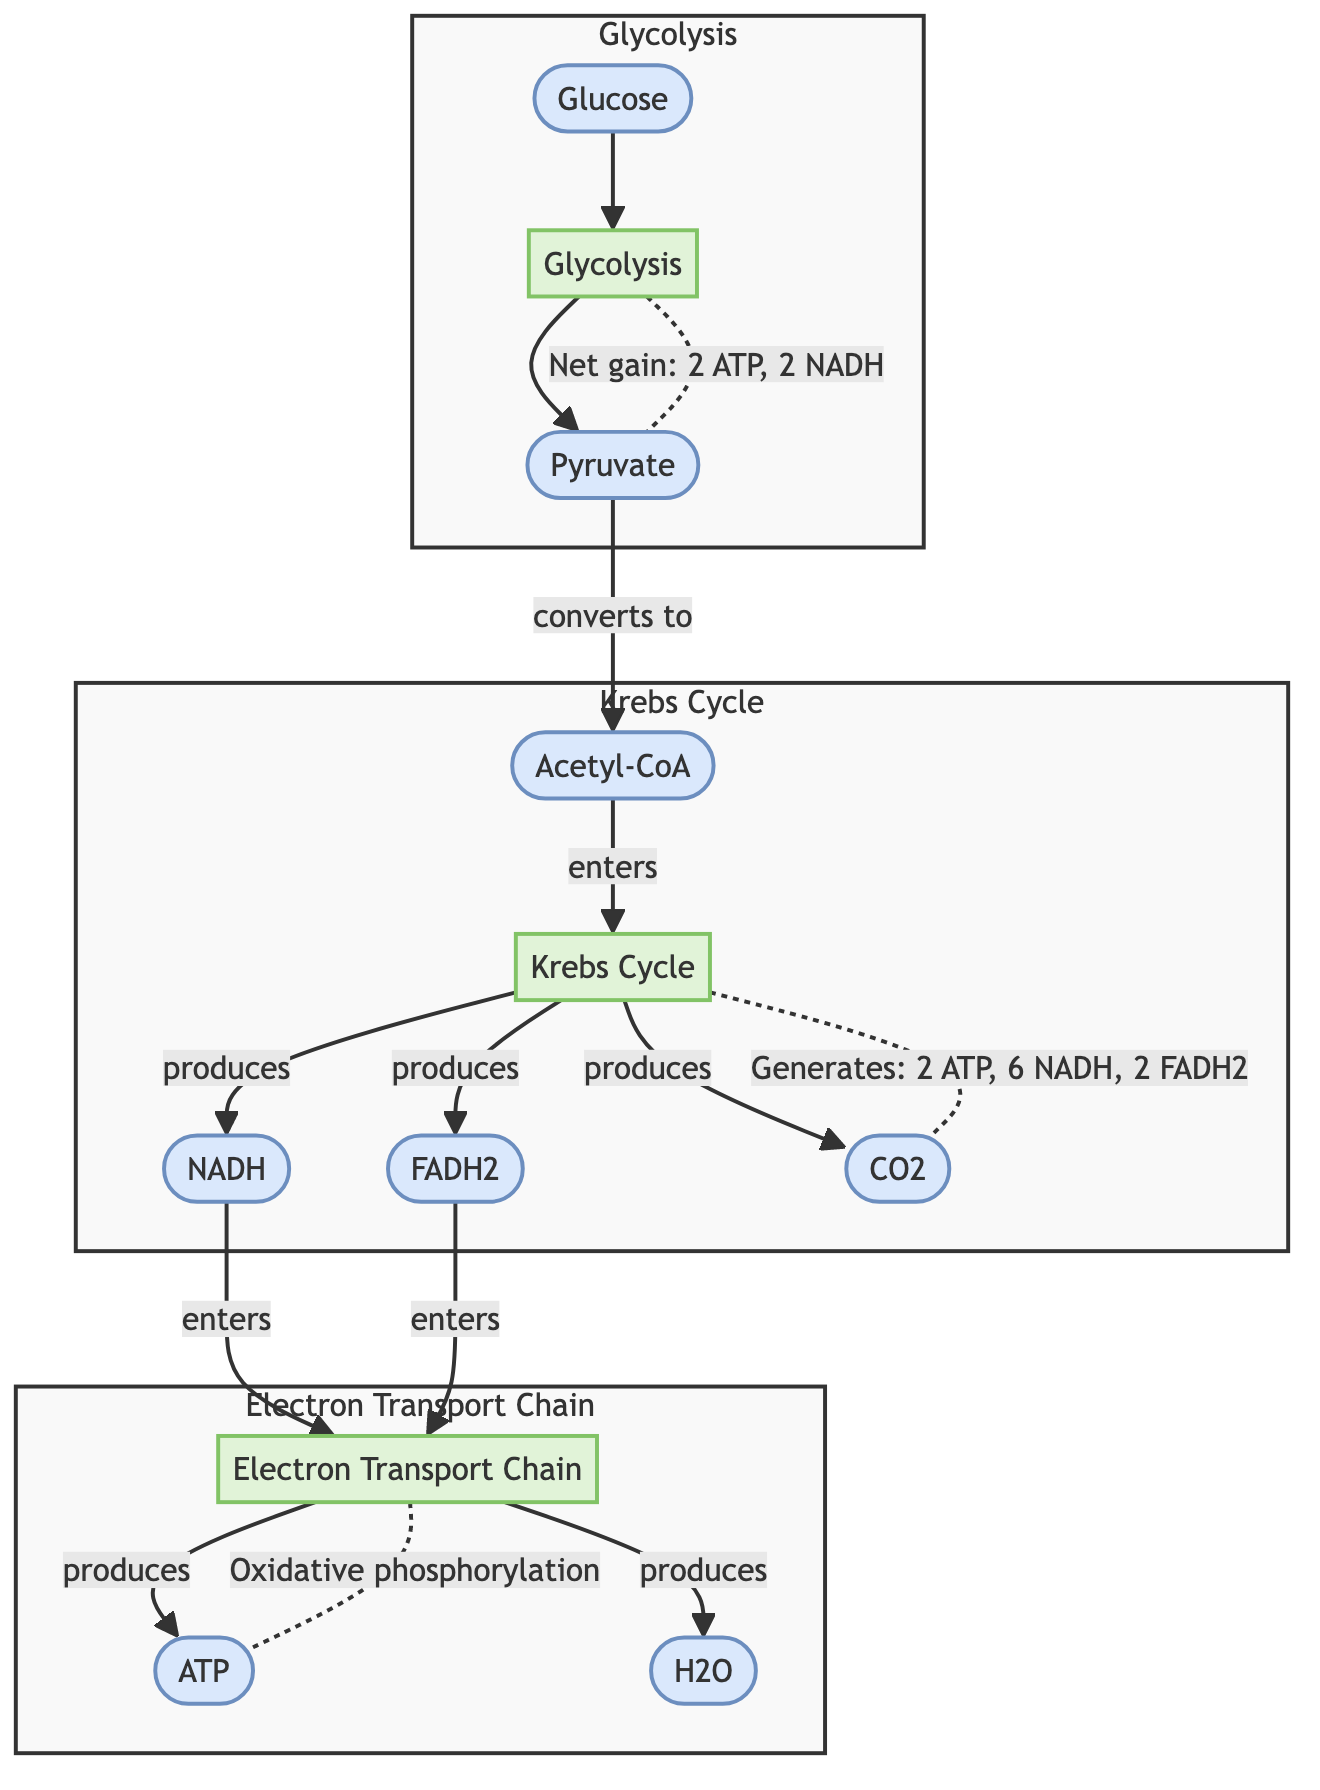What is the starting molecule in the process? The diagram shows that the process begins with glucose, which is indicated as the first node connected to glycolysis.
Answer: Glucose How many ATP molecules are produced in the Krebs Cycle? The diagram specifies that the Krebs Cycle generates 2 ATP molecules as shown in the flow from the Krebs Cycle to CO2 with the annotation.
Answer: 2 ATP What is produced alongside NADH in the Krebs Cycle? The diagram illustrates that alongside NADH, both FADH2 and CO2 are also produced, with each connected to the Krebs Cycle.
Answer: FADH2, CO2 Which process produces water? The Electron Transport Chain is represented in the diagram, and it indicates that water (H2O) is produced at the end of this sequence.
Answer: H2O What is the net gain from glycolysis? The diagram explicitly states the net gain from glycolysis alongside the arrow connecting glycolysis to pyruvate, denoting the production of 2 ATP and 2 NADH.
Answer: 2 ATP, 2 NADH Which molecule enters the Electron Transport Chain from glycolysis? Pyruvate converts to Acetyl-CoA, which then enters the Krebs Cycle. The flow of NADH and FADH2 from Krebs Cycle into the Electron Transport Chain highlights this connection. However, glycolysis itself does not directly send molecules to the Electron Transport Chain.
Answer: None What is the function of the Electron Transport Chain? The diagram indicates that the Electron Transport Chain is responsible for oxidative phosphorylation, which is mentioned in its connection to ATP production in the diagram.
Answer: Oxidative phosphorylation What type of molecular interactions occur in glycolysis? The diagram shows more than one type of product emerging from glycolysis, specifically pyruvate, which demonstrates that glycolysis transforms glucose into pyruvate in an energetic process.
Answer: Conversion of glucose How many NADH molecules are generated by the Krebs Cycle in total? The diagram details that the Krebs Cycle produces 6 NADH molecules, thus this count is directly stated in the flow connecting the Krebs cycle to its products.
Answer: 6 NADH What are the final outputs of the Electron Transport Chain? The Electron Transport Chain outputs ATP and water (H2O), which are indicated as products downstream of the Electron Transport Chain in the diagram.
Answer: ATP, H2O 